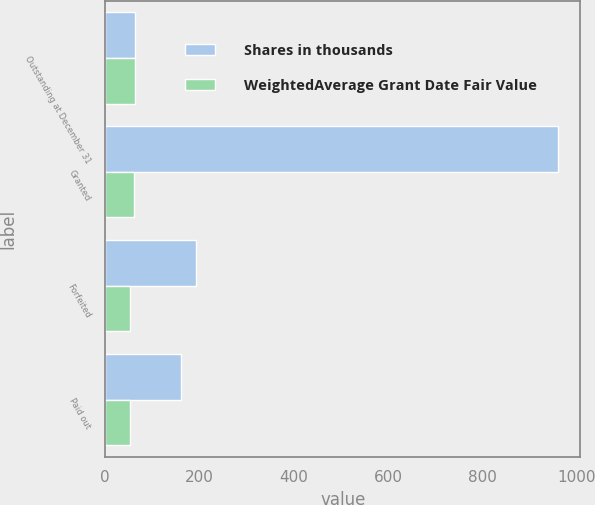<chart> <loc_0><loc_0><loc_500><loc_500><stacked_bar_chart><ecel><fcel>Outstanding at December 31<fcel>Granted<fcel>Forfeited<fcel>Paid out<nl><fcel>Shares in thousands<fcel>63.02<fcel>959<fcel>193<fcel>160<nl><fcel>WeightedAverage Grant Date Fair Value<fcel>63.02<fcel>59.87<fcel>52.71<fcel>52.78<nl></chart> 